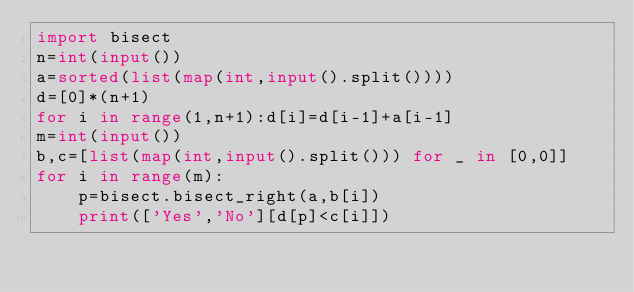<code> <loc_0><loc_0><loc_500><loc_500><_Python_>import bisect
n=int(input())
a=sorted(list(map(int,input().split())))
d=[0]*(n+1)
for i in range(1,n+1):d[i]=d[i-1]+a[i-1]
m=int(input())
b,c=[list(map(int,input().split())) for _ in [0,0]]
for i in range(m):
    p=bisect.bisect_right(a,b[i])
    print(['Yes','No'][d[p]<c[i]])</code> 